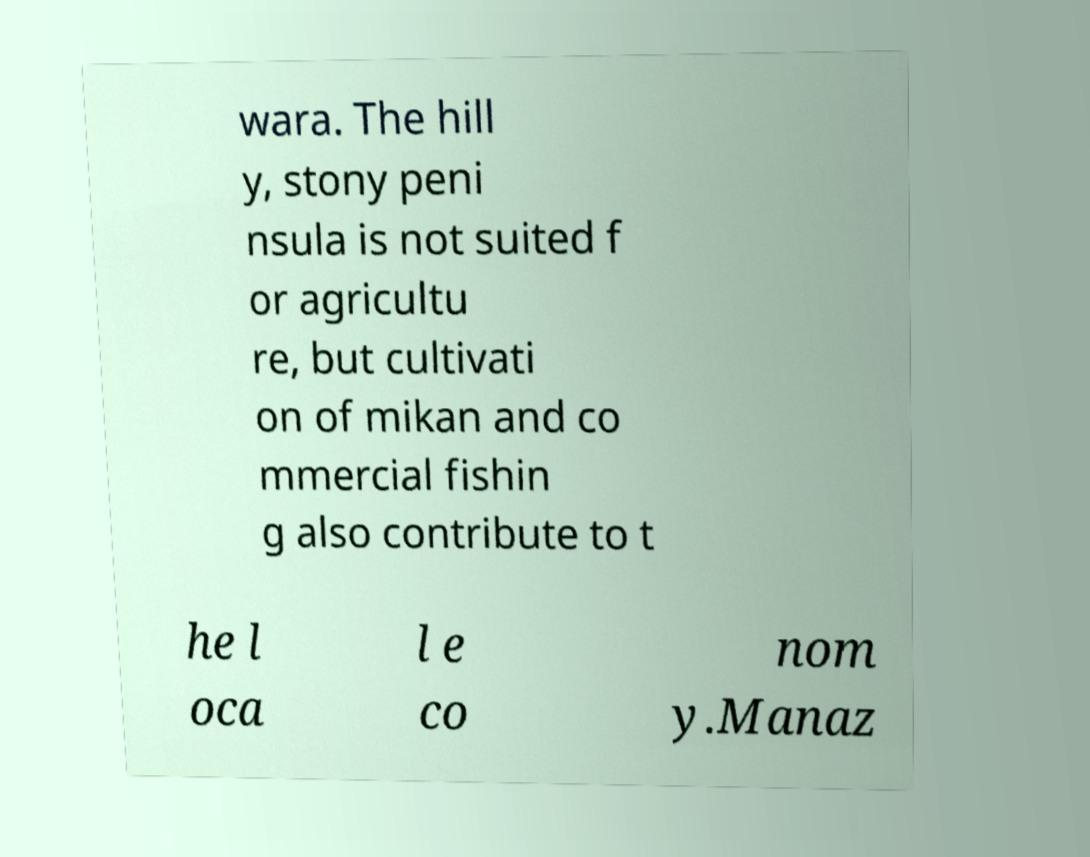Could you assist in decoding the text presented in this image and type it out clearly? wara. The hill y, stony peni nsula is not suited f or agricultu re, but cultivati on of mikan and co mmercial fishin g also contribute to t he l oca l e co nom y.Manaz 